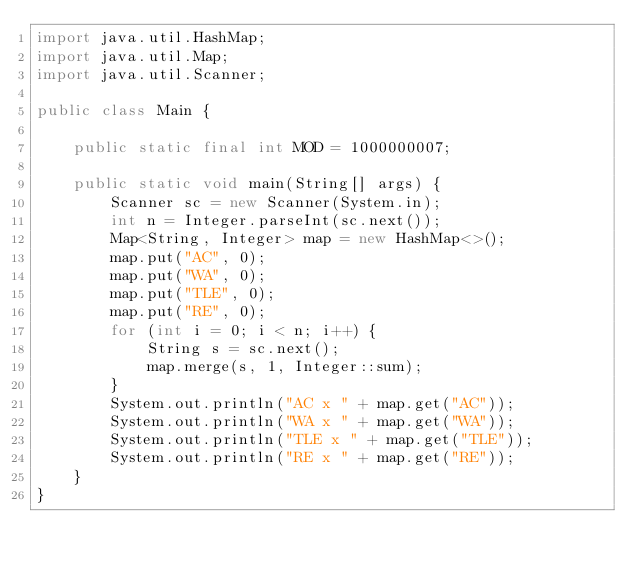<code> <loc_0><loc_0><loc_500><loc_500><_Java_>import java.util.HashMap;
import java.util.Map;
import java.util.Scanner;

public class Main {

    public static final int MOD = 1000000007;

    public static void main(String[] args) {
        Scanner sc = new Scanner(System.in);
        int n = Integer.parseInt(sc.next());
        Map<String, Integer> map = new HashMap<>();
        map.put("AC", 0);
        map.put("WA", 0);
        map.put("TLE", 0);
        map.put("RE", 0);
        for (int i = 0; i < n; i++) {
            String s = sc.next();
            map.merge(s, 1, Integer::sum);
        }
        System.out.println("AC x " + map.get("AC"));
        System.out.println("WA x " + map.get("WA"));
        System.out.println("TLE x " + map.get("TLE"));
        System.out.println("RE x " + map.get("RE"));
    }
}</code> 